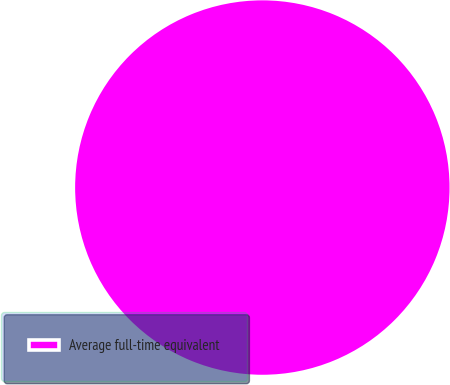Convert chart. <chart><loc_0><loc_0><loc_500><loc_500><pie_chart><fcel>Average full-time equivalent<nl><fcel>100.0%<nl></chart> 